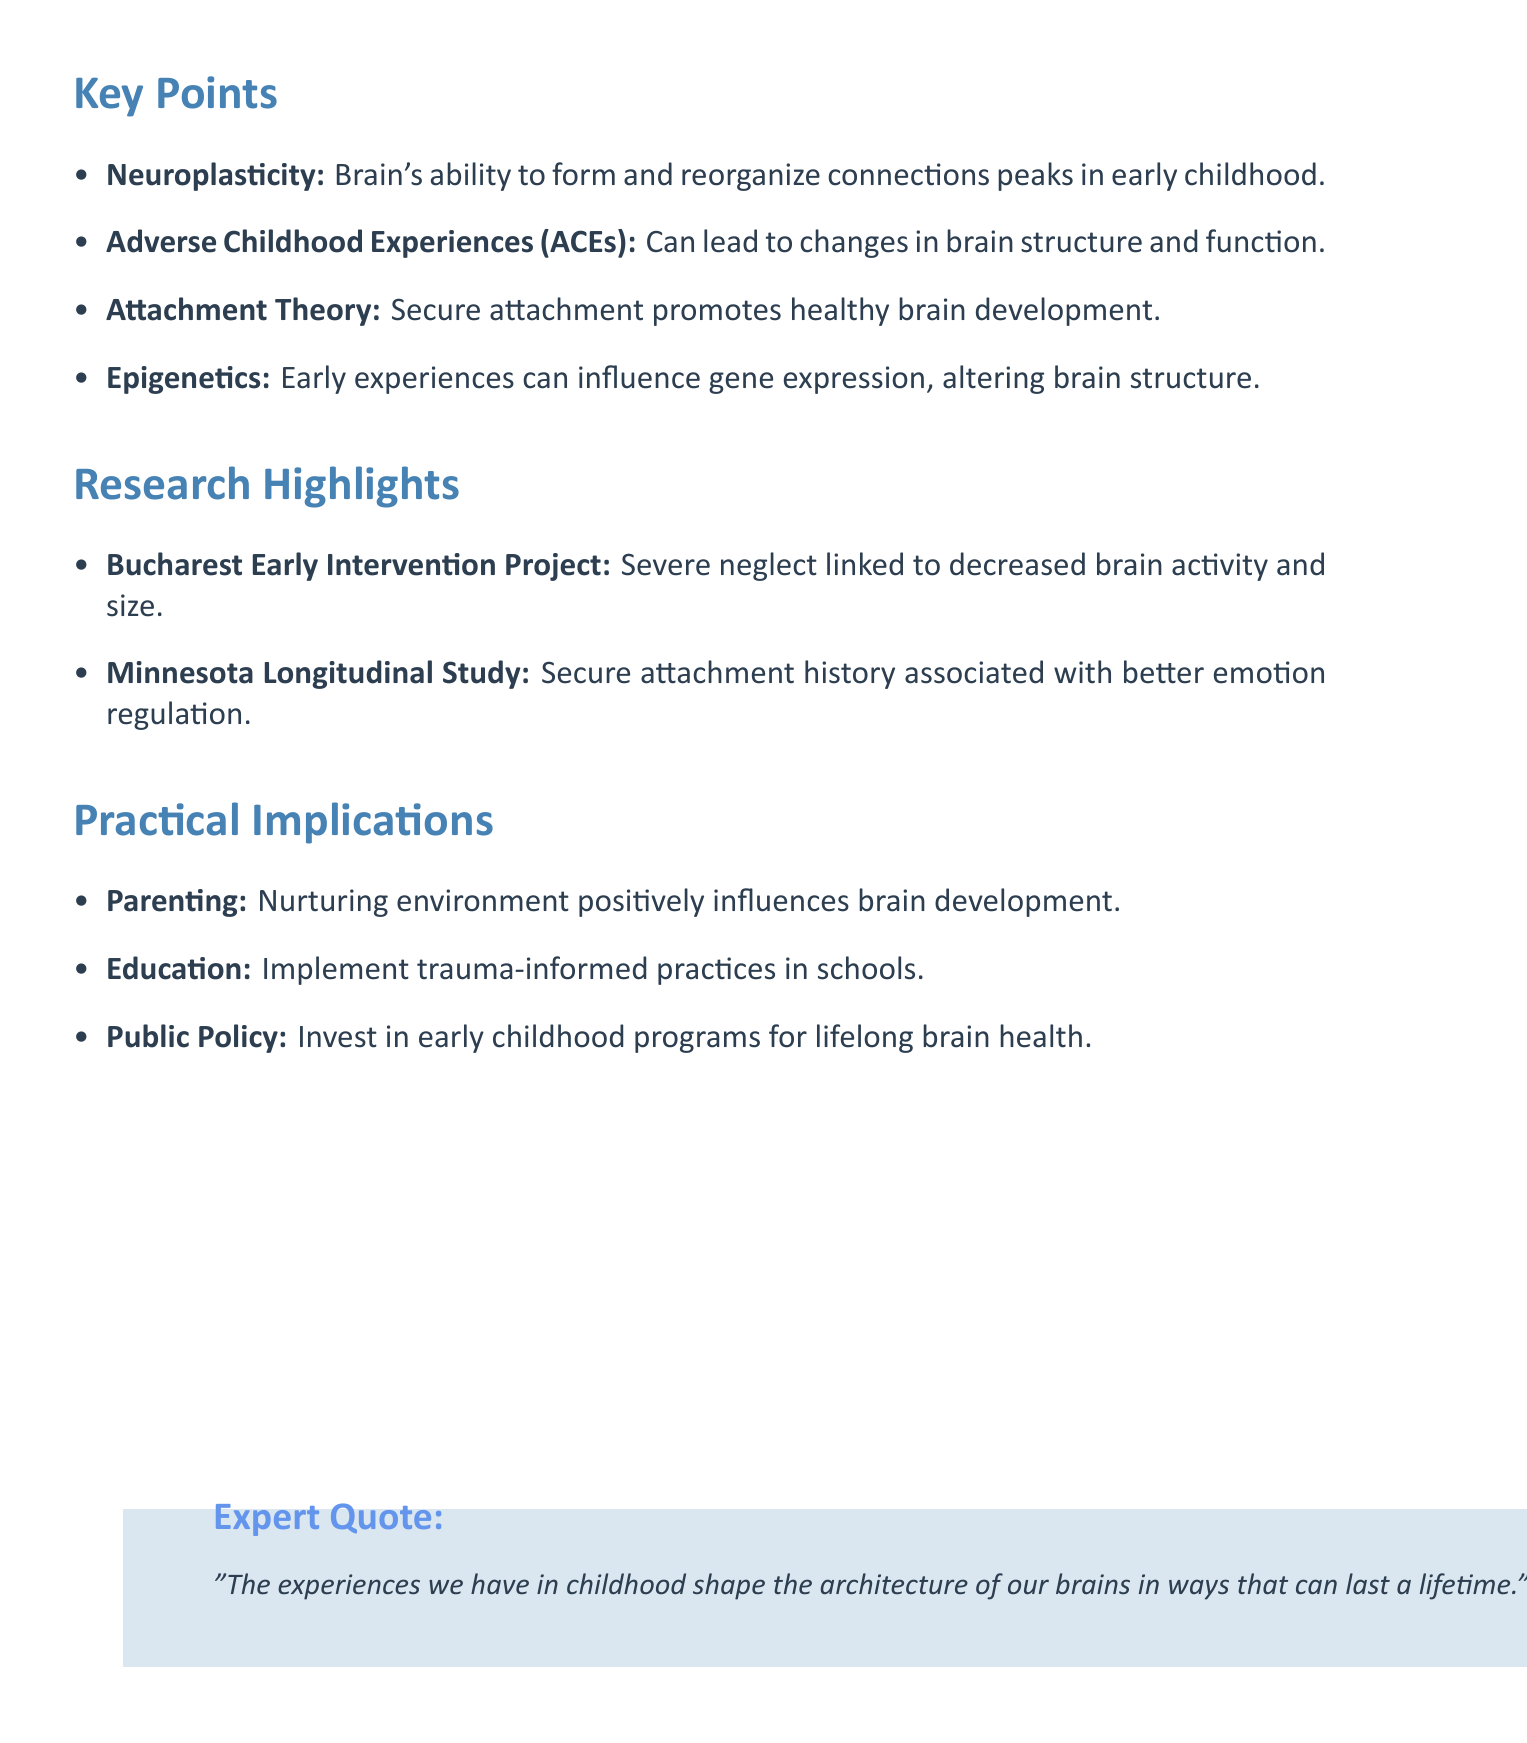What is the title of the podcast? The title is stated in the podcast_info section of the document.
Answer: The Neurobiology of Childhood: Shaping Our Adult Brains Who is the host of the podcast? The host's name is mentioned under podcast_info in the document.
Answer: Dr. Sarah McKay What topic addresses the impact of traumatic events on brain structure? This topic is outlined clearly in the key points section.
Answer: Adverse Childhood Experiences (ACEs) Which study linked severe neglect to brain activity and size? The research highlights section specifies this study’s findings.
Answer: Bucharest Early Intervention Project What is a recommendation for parenting mentioned in the document? The practical implications section includes specific recommendations.
Answer: Providing a nurturing, stimulating environment What aspect of development does secure attachment promote? This is detailed in the key points section regarding attachment theory.
Answer: Healthy brain development Who stated the quote about childhood experiences shaping brain architecture? The expert quotes section identifies the speaker of the quote.
Answer: Dr. Bruce Perry In what domain is it suggested to implement trauma-informed practices? The practical implications section lists where these practices should be applied.
Answer: Education 